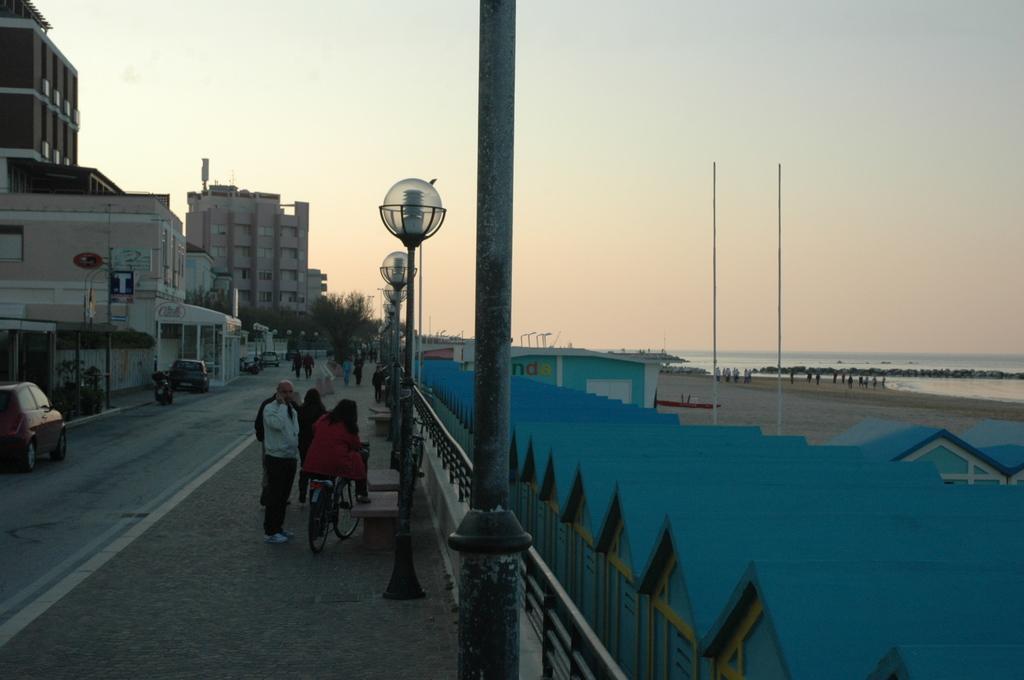In one or two sentences, can you explain what this image depicts? In this picture there is a shed on the right side of the image and there are buildings and cars on the left side of the image, there are people in the center of the image and there are poles in the center of the image. 